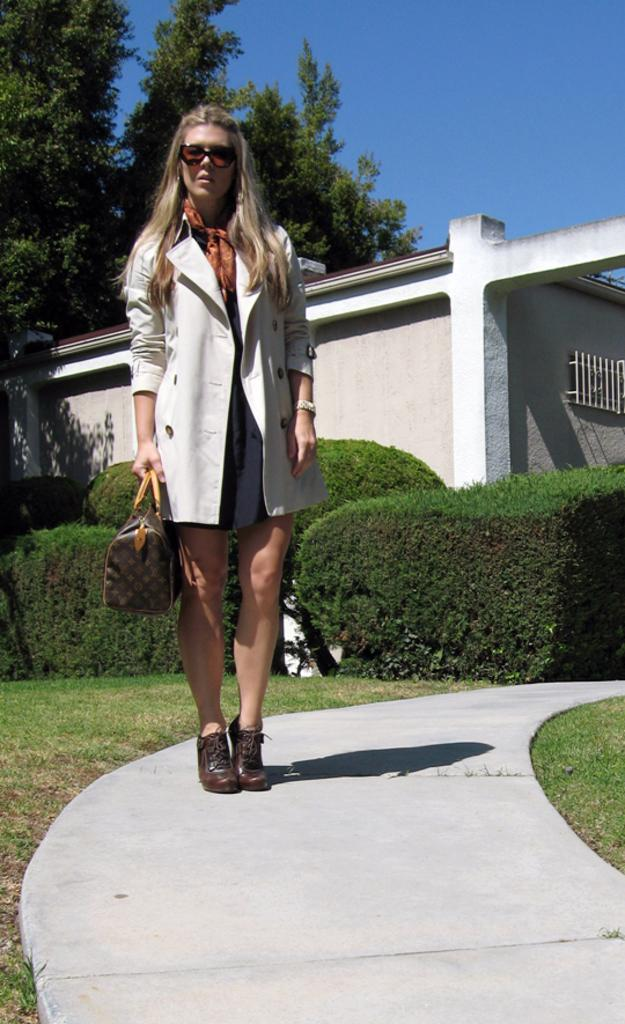Who is present in the image? There is a woman in the image. What is the woman doing in the image? The woman is standing on a path in the image. What is the woman carrying in the image? The woman is carrying a bag in the image. What type of vegetation can be seen in the image? There is grass visible in the image, as well as hedges. What structures are present in the image? There is a wall in the image. What can be seen in the background of the image? There are trees and the sky visible in the background of the image. How many rabbits can be seen hopping around the woman in the image? There are no rabbits present in the image. What organization is the woman representing in the image? There is no indication of any organization in the image. 